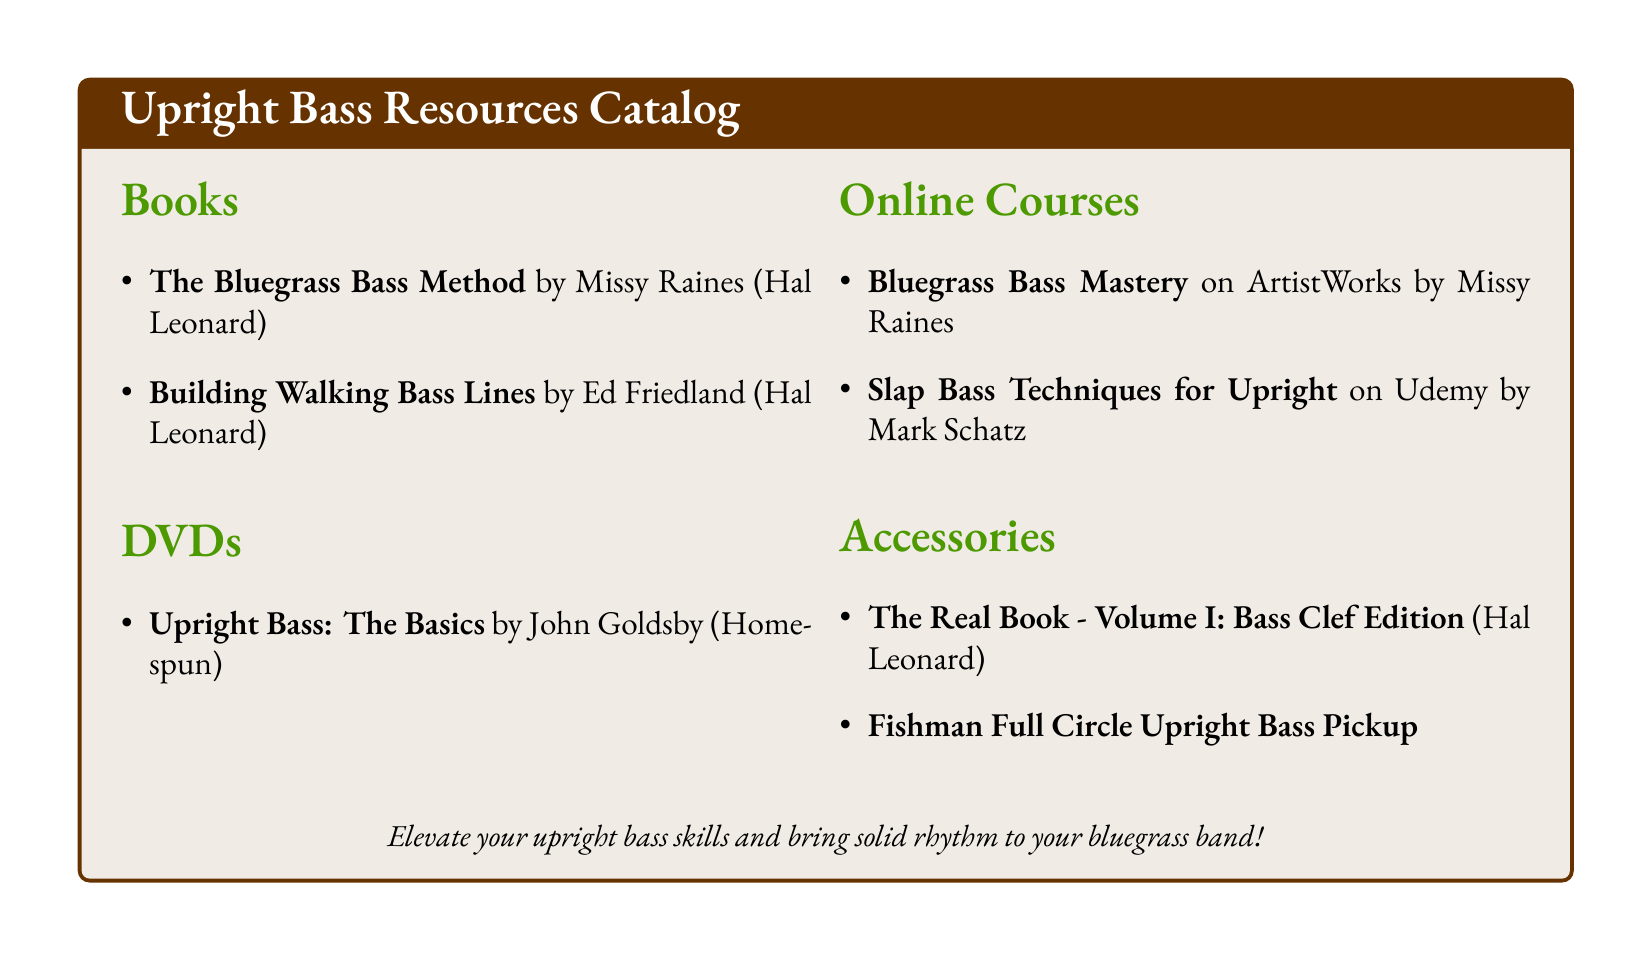What is the title of the book by Missy Raines? The title of the book by Missy Raines is listed under the "Books" section as "The Bluegrass Bass Method."
Answer: The Bluegrass Bass Method Who authored "Building Walking Bass Lines"? The author of "Building Walking Bass Lines" is Ed Friedland, as indicated in the "Books" section.
Answer: Ed Friedland How many DVDs are listed in the catalog? The total number of DVDs can be counted from the "DVDs" section, which shows one DVD available.
Answer: 1 What is the name of the online course taught by Missy Raines? The name of the online course taught by Missy Raines is "Bluegrass Bass Mastery," listed under the "Online Courses" section.
Answer: Bluegrass Bass Mastery Which accessory is specific to upright bass pickups? The accessory that pertains specifically to upright bass pickups is the "Fishman Full Circle Upright Bass Pickup," found in the "Accessories" section.
Answer: Fishman Full Circle Upright Bass Pickup What is the primary focus of the collection? The primary focus of the collection, as highlighted in the introductory statement, is to elevate upright bass skills for musicians.
Answer: Elevate your upright bass skills Who created the DVD titled "Upright Bass: The Basics"? The creator of the DVD titled "Upright Bass: The Basics" is John Goldsby, mentioned in the "DVDs" section.
Answer: John Goldsby What kind of educational resources are included in the catalog? The educational resources include books, DVDs, and online courses, as divided into distinct sections in the document.
Answer: Books, DVDs, Online Courses How is the document styled in terms of color for the title? The document's title is styled in a specific green color identified as "bluegrass."
Answer: Bluegrass 